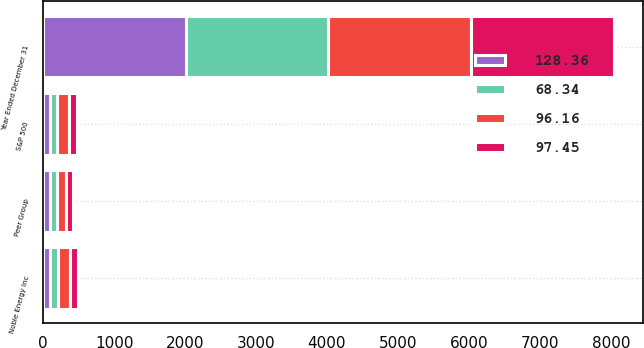Convert chart to OTSL. <chart><loc_0><loc_0><loc_500><loc_500><stacked_bar_chart><ecel><fcel>Year Ended December 31<fcel>Noble Energy Inc<fcel>S&P 500<fcel>Peer Group<nl><fcel>128.36<fcel>2010<fcel>100<fcel>100<fcel>100<nl><fcel>68.34<fcel>2011<fcel>110.64<fcel>102.11<fcel>96.16<nl><fcel>97.45<fcel>2012<fcel>120.4<fcel>118.45<fcel>97.45<nl><fcel>96.16<fcel>2013<fcel>162.63<fcel>156.82<fcel>128.36<nl></chart> 